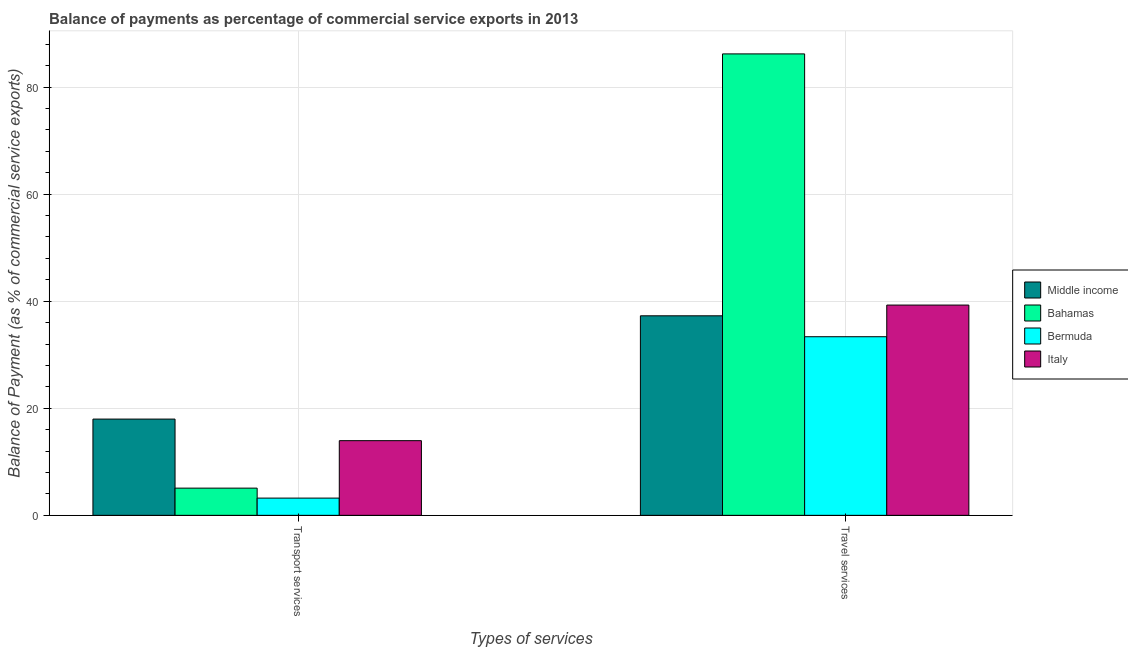What is the label of the 2nd group of bars from the left?
Your answer should be compact. Travel services. What is the balance of payments of transport services in Bermuda?
Provide a succinct answer. 3.22. Across all countries, what is the maximum balance of payments of transport services?
Your answer should be very brief. 17.98. Across all countries, what is the minimum balance of payments of transport services?
Offer a terse response. 3.22. In which country was the balance of payments of travel services maximum?
Offer a very short reply. Bahamas. In which country was the balance of payments of transport services minimum?
Give a very brief answer. Bermuda. What is the total balance of payments of travel services in the graph?
Make the answer very short. 196.12. What is the difference between the balance of payments of travel services in Italy and that in Bermuda?
Offer a terse response. 5.91. What is the difference between the balance of payments of transport services in Middle income and the balance of payments of travel services in Italy?
Your response must be concise. -21.3. What is the average balance of payments of transport services per country?
Provide a short and direct response. 10.06. What is the difference between the balance of payments of travel services and balance of payments of transport services in Bahamas?
Keep it short and to the point. 81.12. What is the ratio of the balance of payments of travel services in Bermuda to that in Middle income?
Offer a terse response. 0.9. What does the 2nd bar from the left in Transport services represents?
Ensure brevity in your answer.  Bahamas. What does the 2nd bar from the right in Transport services represents?
Provide a succinct answer. Bermuda. How many bars are there?
Offer a terse response. 8. Are all the bars in the graph horizontal?
Your answer should be very brief. No. Does the graph contain grids?
Provide a succinct answer. Yes. What is the title of the graph?
Give a very brief answer. Balance of payments as percentage of commercial service exports in 2013. Does "Myanmar" appear as one of the legend labels in the graph?
Offer a terse response. No. What is the label or title of the X-axis?
Give a very brief answer. Types of services. What is the label or title of the Y-axis?
Ensure brevity in your answer.  Balance of Payment (as % of commercial service exports). What is the Balance of Payment (as % of commercial service exports) of Middle income in Transport services?
Give a very brief answer. 17.98. What is the Balance of Payment (as % of commercial service exports) in Bahamas in Transport services?
Your response must be concise. 5.08. What is the Balance of Payment (as % of commercial service exports) in Bermuda in Transport services?
Your response must be concise. 3.22. What is the Balance of Payment (as % of commercial service exports) in Italy in Transport services?
Provide a succinct answer. 13.95. What is the Balance of Payment (as % of commercial service exports) of Middle income in Travel services?
Provide a succinct answer. 37.27. What is the Balance of Payment (as % of commercial service exports) in Bahamas in Travel services?
Make the answer very short. 86.2. What is the Balance of Payment (as % of commercial service exports) of Bermuda in Travel services?
Your answer should be compact. 33.37. What is the Balance of Payment (as % of commercial service exports) in Italy in Travel services?
Offer a terse response. 39.28. Across all Types of services, what is the maximum Balance of Payment (as % of commercial service exports) in Middle income?
Give a very brief answer. 37.27. Across all Types of services, what is the maximum Balance of Payment (as % of commercial service exports) in Bahamas?
Keep it short and to the point. 86.2. Across all Types of services, what is the maximum Balance of Payment (as % of commercial service exports) of Bermuda?
Provide a short and direct response. 33.37. Across all Types of services, what is the maximum Balance of Payment (as % of commercial service exports) in Italy?
Keep it short and to the point. 39.28. Across all Types of services, what is the minimum Balance of Payment (as % of commercial service exports) in Middle income?
Offer a terse response. 17.98. Across all Types of services, what is the minimum Balance of Payment (as % of commercial service exports) of Bahamas?
Make the answer very short. 5.08. Across all Types of services, what is the minimum Balance of Payment (as % of commercial service exports) in Bermuda?
Provide a succinct answer. 3.22. Across all Types of services, what is the minimum Balance of Payment (as % of commercial service exports) of Italy?
Your answer should be compact. 13.95. What is the total Balance of Payment (as % of commercial service exports) in Middle income in the graph?
Your answer should be very brief. 55.26. What is the total Balance of Payment (as % of commercial service exports) of Bahamas in the graph?
Provide a short and direct response. 91.28. What is the total Balance of Payment (as % of commercial service exports) of Bermuda in the graph?
Make the answer very short. 36.59. What is the total Balance of Payment (as % of commercial service exports) in Italy in the graph?
Make the answer very short. 53.23. What is the difference between the Balance of Payment (as % of commercial service exports) in Middle income in Transport services and that in Travel services?
Provide a short and direct response. -19.29. What is the difference between the Balance of Payment (as % of commercial service exports) in Bahamas in Transport services and that in Travel services?
Offer a terse response. -81.12. What is the difference between the Balance of Payment (as % of commercial service exports) of Bermuda in Transport services and that in Travel services?
Your response must be concise. -30.15. What is the difference between the Balance of Payment (as % of commercial service exports) of Italy in Transport services and that in Travel services?
Make the answer very short. -25.33. What is the difference between the Balance of Payment (as % of commercial service exports) in Middle income in Transport services and the Balance of Payment (as % of commercial service exports) in Bahamas in Travel services?
Ensure brevity in your answer.  -68.22. What is the difference between the Balance of Payment (as % of commercial service exports) in Middle income in Transport services and the Balance of Payment (as % of commercial service exports) in Bermuda in Travel services?
Make the answer very short. -15.39. What is the difference between the Balance of Payment (as % of commercial service exports) of Middle income in Transport services and the Balance of Payment (as % of commercial service exports) of Italy in Travel services?
Give a very brief answer. -21.3. What is the difference between the Balance of Payment (as % of commercial service exports) in Bahamas in Transport services and the Balance of Payment (as % of commercial service exports) in Bermuda in Travel services?
Make the answer very short. -28.28. What is the difference between the Balance of Payment (as % of commercial service exports) of Bahamas in Transport services and the Balance of Payment (as % of commercial service exports) of Italy in Travel services?
Keep it short and to the point. -34.2. What is the difference between the Balance of Payment (as % of commercial service exports) of Bermuda in Transport services and the Balance of Payment (as % of commercial service exports) of Italy in Travel services?
Offer a terse response. -36.06. What is the average Balance of Payment (as % of commercial service exports) in Middle income per Types of services?
Provide a succinct answer. 27.63. What is the average Balance of Payment (as % of commercial service exports) in Bahamas per Types of services?
Give a very brief answer. 45.64. What is the average Balance of Payment (as % of commercial service exports) of Bermuda per Types of services?
Your answer should be compact. 18.29. What is the average Balance of Payment (as % of commercial service exports) in Italy per Types of services?
Ensure brevity in your answer.  26.62. What is the difference between the Balance of Payment (as % of commercial service exports) of Middle income and Balance of Payment (as % of commercial service exports) of Bahamas in Transport services?
Provide a succinct answer. 12.9. What is the difference between the Balance of Payment (as % of commercial service exports) of Middle income and Balance of Payment (as % of commercial service exports) of Bermuda in Transport services?
Your answer should be very brief. 14.76. What is the difference between the Balance of Payment (as % of commercial service exports) in Middle income and Balance of Payment (as % of commercial service exports) in Italy in Transport services?
Your answer should be compact. 4.03. What is the difference between the Balance of Payment (as % of commercial service exports) of Bahamas and Balance of Payment (as % of commercial service exports) of Bermuda in Transport services?
Your response must be concise. 1.86. What is the difference between the Balance of Payment (as % of commercial service exports) of Bahamas and Balance of Payment (as % of commercial service exports) of Italy in Transport services?
Provide a short and direct response. -8.87. What is the difference between the Balance of Payment (as % of commercial service exports) of Bermuda and Balance of Payment (as % of commercial service exports) of Italy in Transport services?
Your response must be concise. -10.73. What is the difference between the Balance of Payment (as % of commercial service exports) of Middle income and Balance of Payment (as % of commercial service exports) of Bahamas in Travel services?
Make the answer very short. -48.93. What is the difference between the Balance of Payment (as % of commercial service exports) of Middle income and Balance of Payment (as % of commercial service exports) of Bermuda in Travel services?
Offer a terse response. 3.91. What is the difference between the Balance of Payment (as % of commercial service exports) in Middle income and Balance of Payment (as % of commercial service exports) in Italy in Travel services?
Your answer should be compact. -2. What is the difference between the Balance of Payment (as % of commercial service exports) of Bahamas and Balance of Payment (as % of commercial service exports) of Bermuda in Travel services?
Provide a short and direct response. 52.84. What is the difference between the Balance of Payment (as % of commercial service exports) of Bahamas and Balance of Payment (as % of commercial service exports) of Italy in Travel services?
Provide a succinct answer. 46.92. What is the difference between the Balance of Payment (as % of commercial service exports) of Bermuda and Balance of Payment (as % of commercial service exports) of Italy in Travel services?
Your answer should be very brief. -5.91. What is the ratio of the Balance of Payment (as % of commercial service exports) of Middle income in Transport services to that in Travel services?
Your answer should be very brief. 0.48. What is the ratio of the Balance of Payment (as % of commercial service exports) in Bahamas in Transport services to that in Travel services?
Provide a succinct answer. 0.06. What is the ratio of the Balance of Payment (as % of commercial service exports) of Bermuda in Transport services to that in Travel services?
Offer a very short reply. 0.1. What is the ratio of the Balance of Payment (as % of commercial service exports) of Italy in Transport services to that in Travel services?
Make the answer very short. 0.36. What is the difference between the highest and the second highest Balance of Payment (as % of commercial service exports) in Middle income?
Offer a very short reply. 19.29. What is the difference between the highest and the second highest Balance of Payment (as % of commercial service exports) in Bahamas?
Offer a terse response. 81.12. What is the difference between the highest and the second highest Balance of Payment (as % of commercial service exports) of Bermuda?
Give a very brief answer. 30.15. What is the difference between the highest and the second highest Balance of Payment (as % of commercial service exports) in Italy?
Offer a terse response. 25.33. What is the difference between the highest and the lowest Balance of Payment (as % of commercial service exports) of Middle income?
Your response must be concise. 19.29. What is the difference between the highest and the lowest Balance of Payment (as % of commercial service exports) of Bahamas?
Your answer should be compact. 81.12. What is the difference between the highest and the lowest Balance of Payment (as % of commercial service exports) of Bermuda?
Keep it short and to the point. 30.15. What is the difference between the highest and the lowest Balance of Payment (as % of commercial service exports) of Italy?
Ensure brevity in your answer.  25.33. 